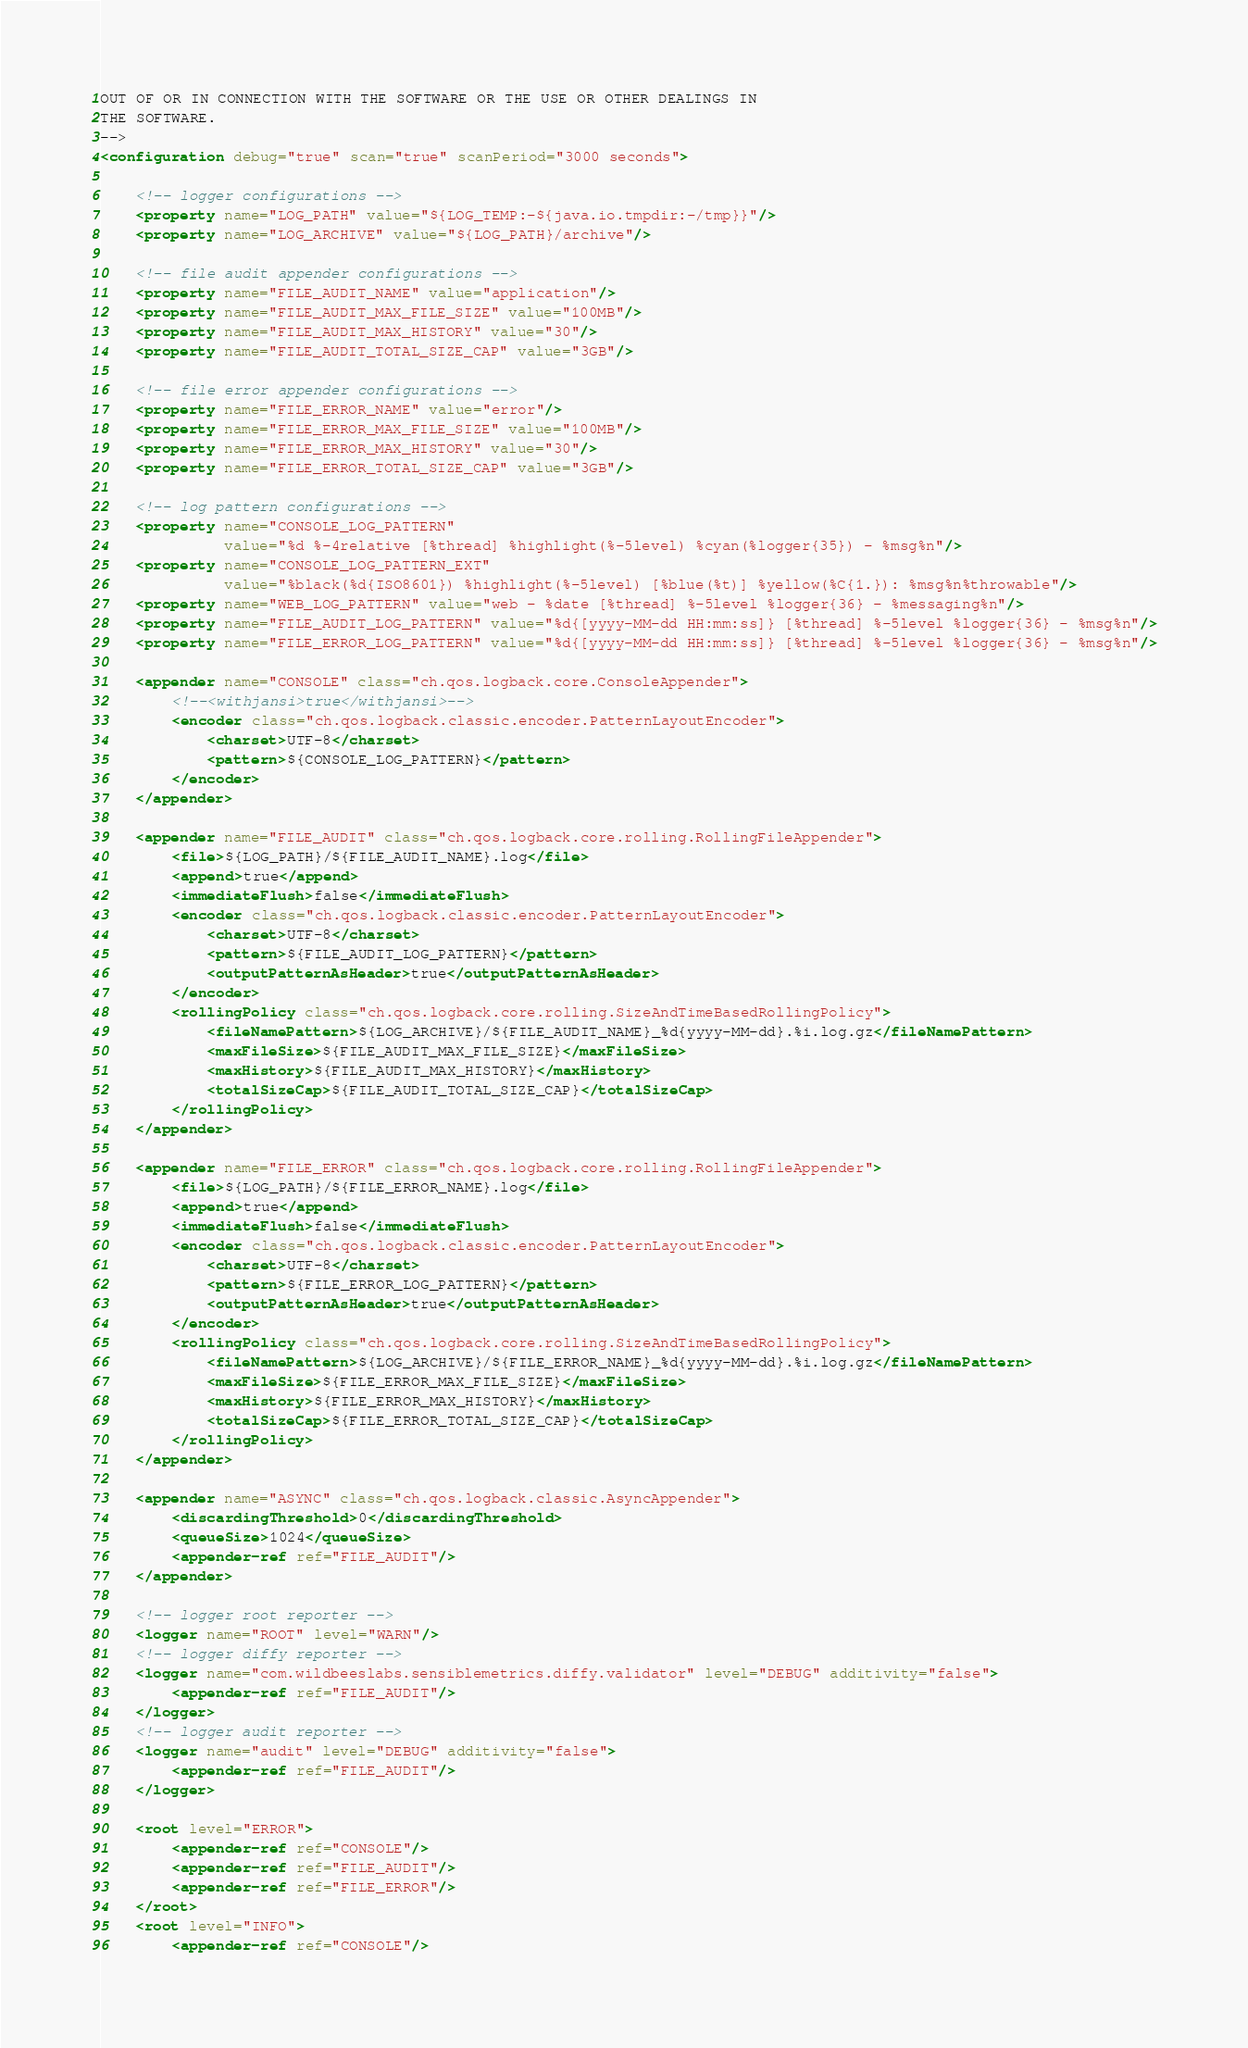<code> <loc_0><loc_0><loc_500><loc_500><_XML_>OUT OF OR IN CONNECTION WITH THE SOFTWARE OR THE USE OR OTHER DEALINGS IN
THE SOFTWARE.
-->
<configuration debug="true" scan="true" scanPeriod="3000 seconds">

    <!-- logger configurations -->
    <property name="LOG_PATH" value="${LOG_TEMP:-${java.io.tmpdir:-/tmp}}"/>
    <property name="LOG_ARCHIVE" value="${LOG_PATH}/archive"/>

    <!-- file audit appender configurations -->
    <property name="FILE_AUDIT_NAME" value="application"/>
    <property name="FILE_AUDIT_MAX_FILE_SIZE" value="100MB"/>
    <property name="FILE_AUDIT_MAX_HISTORY" value="30"/>
    <property name="FILE_AUDIT_TOTAL_SIZE_CAP" value="3GB"/>

    <!-- file error appender configurations -->
    <property name="FILE_ERROR_NAME" value="error"/>
    <property name="FILE_ERROR_MAX_FILE_SIZE" value="100MB"/>
    <property name="FILE_ERROR_MAX_HISTORY" value="30"/>
    <property name="FILE_ERROR_TOTAL_SIZE_CAP" value="3GB"/>

    <!-- log pattern configurations -->
    <property name="CONSOLE_LOG_PATTERN"
              value="%d %-4relative [%thread] %highlight(%-5level) %cyan(%logger{35}) - %msg%n"/>
    <property name="CONSOLE_LOG_PATTERN_EXT"
              value="%black(%d{ISO8601}) %highlight(%-5level) [%blue(%t)] %yellow(%C{1.}): %msg%n%throwable"/>
    <property name="WEB_LOG_PATTERN" value="web - %date [%thread] %-5level %logger{36} - %messaging%n"/>
    <property name="FILE_AUDIT_LOG_PATTERN" value="%d{[yyyy-MM-dd HH:mm:ss]} [%thread] %-5level %logger{36} - %msg%n"/>
    <property name="FILE_ERROR_LOG_PATTERN" value="%d{[yyyy-MM-dd HH:mm:ss]} [%thread] %-5level %logger{36} - %msg%n"/>

    <appender name="CONSOLE" class="ch.qos.logback.core.ConsoleAppender">
        <!--<withjansi>true</withjansi>-->
        <encoder class="ch.qos.logback.classic.encoder.PatternLayoutEncoder">
            <charset>UTF-8</charset>
            <pattern>${CONSOLE_LOG_PATTERN}</pattern>
        </encoder>
    </appender>

    <appender name="FILE_AUDIT" class="ch.qos.logback.core.rolling.RollingFileAppender">
        <file>${LOG_PATH}/${FILE_AUDIT_NAME}.log</file>
        <append>true</append>
        <immediateFlush>false</immediateFlush>
        <encoder class="ch.qos.logback.classic.encoder.PatternLayoutEncoder">
            <charset>UTF-8</charset>
            <pattern>${FILE_AUDIT_LOG_PATTERN}</pattern>
            <outputPatternAsHeader>true</outputPatternAsHeader>
        </encoder>
        <rollingPolicy class="ch.qos.logback.core.rolling.SizeAndTimeBasedRollingPolicy">
            <fileNamePattern>${LOG_ARCHIVE}/${FILE_AUDIT_NAME}_%d{yyyy-MM-dd}.%i.log.gz</fileNamePattern>
            <maxFileSize>${FILE_AUDIT_MAX_FILE_SIZE}</maxFileSize>
            <maxHistory>${FILE_AUDIT_MAX_HISTORY}</maxHistory>
            <totalSizeCap>${FILE_AUDIT_TOTAL_SIZE_CAP}</totalSizeCap>
        </rollingPolicy>
    </appender>

    <appender name="FILE_ERROR" class="ch.qos.logback.core.rolling.RollingFileAppender">
        <file>${LOG_PATH}/${FILE_ERROR_NAME}.log</file>
        <append>true</append>
        <immediateFlush>false</immediateFlush>
        <encoder class="ch.qos.logback.classic.encoder.PatternLayoutEncoder">
            <charset>UTF-8</charset>
            <pattern>${FILE_ERROR_LOG_PATTERN}</pattern>
            <outputPatternAsHeader>true</outputPatternAsHeader>
        </encoder>
        <rollingPolicy class="ch.qos.logback.core.rolling.SizeAndTimeBasedRollingPolicy">
            <fileNamePattern>${LOG_ARCHIVE}/${FILE_ERROR_NAME}_%d{yyyy-MM-dd}.%i.log.gz</fileNamePattern>
            <maxFileSize>${FILE_ERROR_MAX_FILE_SIZE}</maxFileSize>
            <maxHistory>${FILE_ERROR_MAX_HISTORY}</maxHistory>
            <totalSizeCap>${FILE_ERROR_TOTAL_SIZE_CAP}</totalSizeCap>
        </rollingPolicy>
    </appender>

    <appender name="ASYNC" class="ch.qos.logback.classic.AsyncAppender">
        <discardingThreshold>0</discardingThreshold>
        <queueSize>1024</queueSize>
        <appender-ref ref="FILE_AUDIT"/>
    </appender>

    <!-- logger root reporter -->
    <logger name="ROOT" level="WARN"/>
    <!-- logger diffy reporter -->
    <logger name="com.wildbeeslabs.sensiblemetrics.diffy.validator" level="DEBUG" additivity="false">
        <appender-ref ref="FILE_AUDIT"/>
    </logger>
    <!-- logger audit reporter -->
    <logger name="audit" level="DEBUG" additivity="false">
        <appender-ref ref="FILE_AUDIT"/>
    </logger>

    <root level="ERROR">
        <appender-ref ref="CONSOLE"/>
        <appender-ref ref="FILE_AUDIT"/>
        <appender-ref ref="FILE_ERROR"/>
    </root>
    <root level="INFO">
        <appender-ref ref="CONSOLE"/></code> 